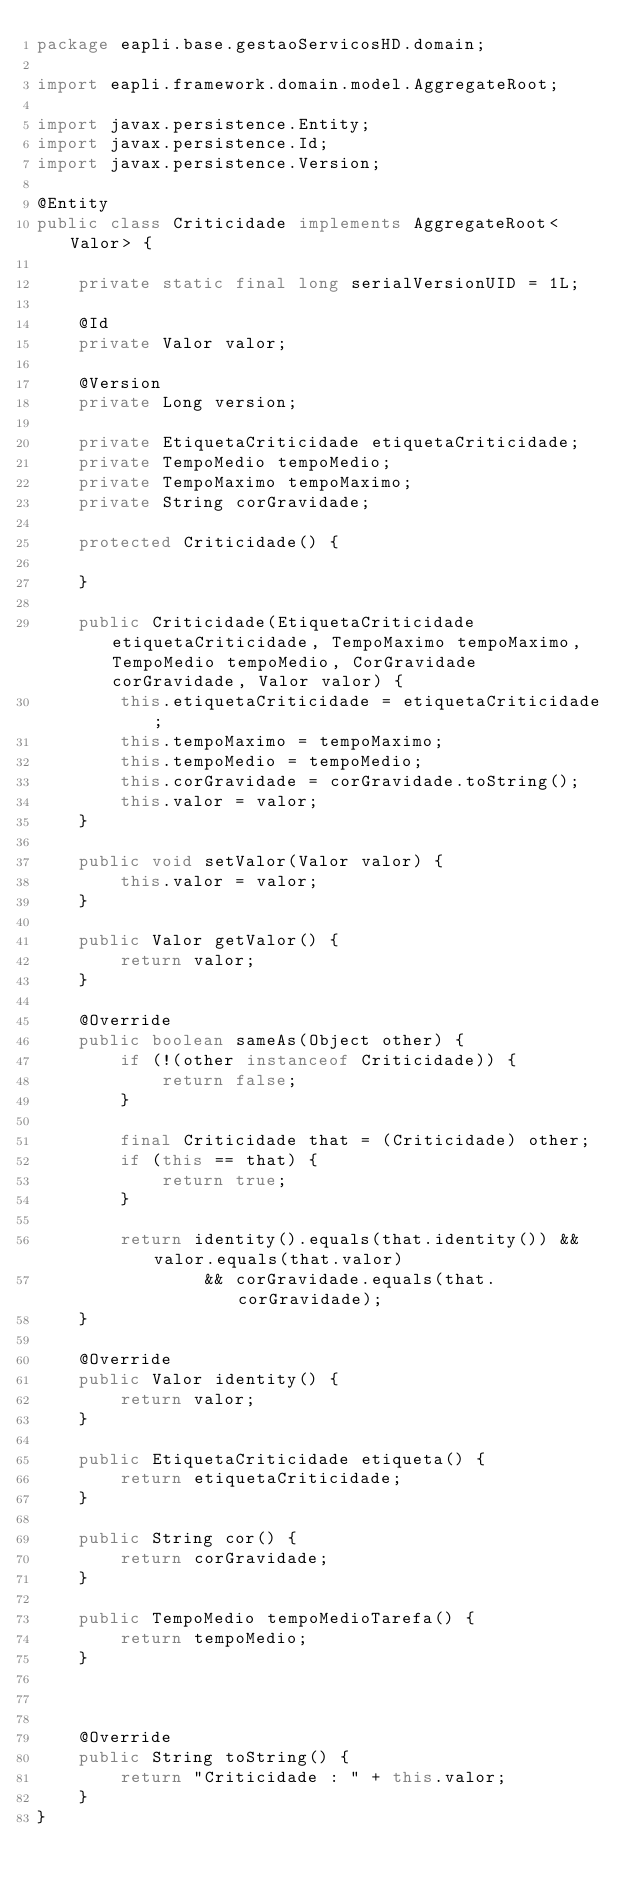<code> <loc_0><loc_0><loc_500><loc_500><_Java_>package eapli.base.gestaoServicosHD.domain;

import eapli.framework.domain.model.AggregateRoot;

import javax.persistence.Entity;
import javax.persistence.Id;
import javax.persistence.Version;

@Entity
public class Criticidade implements AggregateRoot<Valor> {

    private static final long serialVersionUID = 1L;

    @Id
    private Valor valor;

    @Version
    private Long version;

    private EtiquetaCriticidade etiquetaCriticidade;
    private TempoMedio tempoMedio;
    private TempoMaximo tempoMaximo;
    private String corGravidade;

    protected Criticidade() {

    }

    public Criticidade(EtiquetaCriticidade etiquetaCriticidade, TempoMaximo tempoMaximo, TempoMedio tempoMedio, CorGravidade corGravidade, Valor valor) {
        this.etiquetaCriticidade = etiquetaCriticidade;
        this.tempoMaximo = tempoMaximo;
        this.tempoMedio = tempoMedio;
        this.corGravidade = corGravidade.toString();
        this.valor = valor;
    }

    public void setValor(Valor valor) {
        this.valor = valor;
    }

    public Valor getValor() {
        return valor;
    }

    @Override
    public boolean sameAs(Object other) {
        if (!(other instanceof Criticidade)) {
            return false;
        }

        final Criticidade that = (Criticidade) other;
        if (this == that) {
            return true;
        }

        return identity().equals(that.identity()) && valor.equals(that.valor)
                && corGravidade.equals(that.corGravidade);
    }

    @Override
    public Valor identity() {
        return valor;
    }

    public EtiquetaCriticidade etiqueta() {
        return etiquetaCriticidade;
    }

    public String cor() {
        return corGravidade;
    }

    public TempoMedio tempoMedioTarefa() {
        return tempoMedio;
    }
    
    

    @Override
    public String toString() {
        return "Criticidade : " + this.valor;
    }
}
</code> 